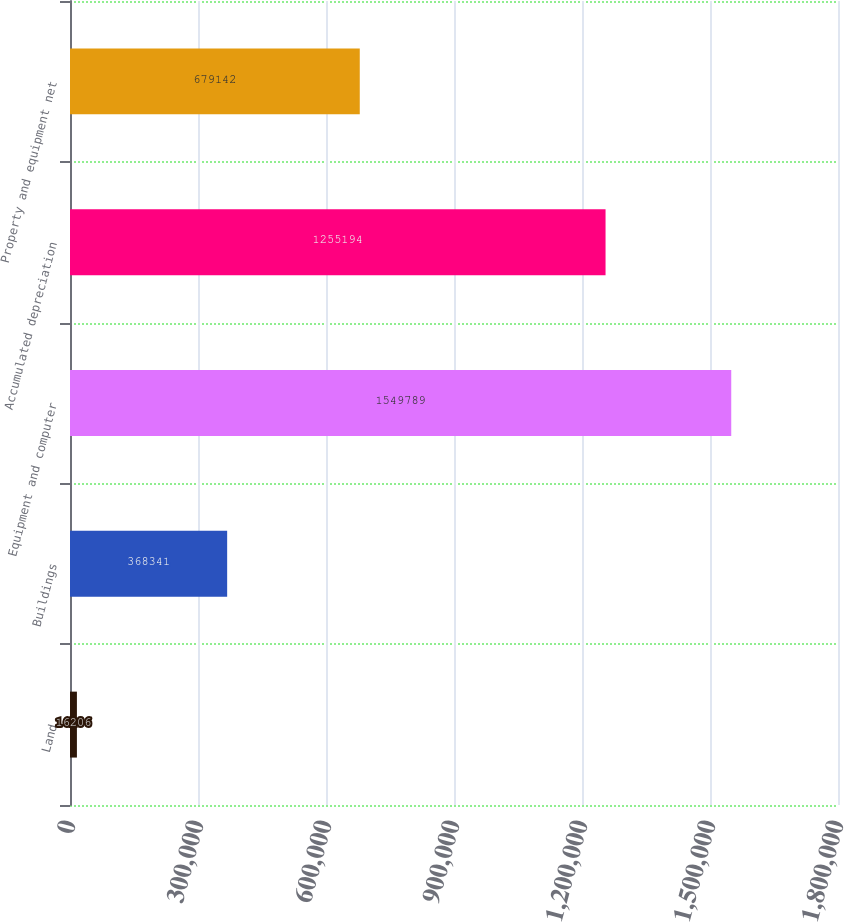Convert chart. <chart><loc_0><loc_0><loc_500><loc_500><bar_chart><fcel>Land<fcel>Buildings<fcel>Equipment and computer<fcel>Accumulated depreciation<fcel>Property and equipment net<nl><fcel>16206<fcel>368341<fcel>1.54979e+06<fcel>1.25519e+06<fcel>679142<nl></chart> 